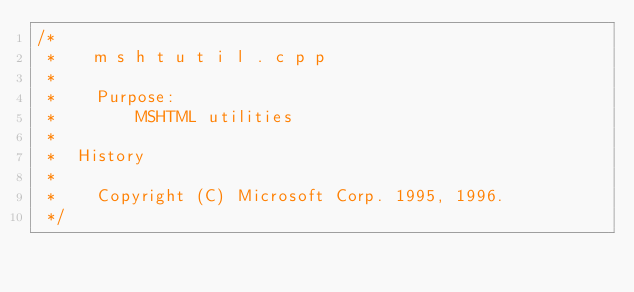Convert code to text. <code><loc_0><loc_0><loc_500><loc_500><_C_>/*
 *    m s h t u t i l . c p p
 *    
 *    Purpose:
 *        MSHTML utilities
 *
 *  History
 *    
 *    Copyright (C) Microsoft Corp. 1995, 1996.
 */
</code> 